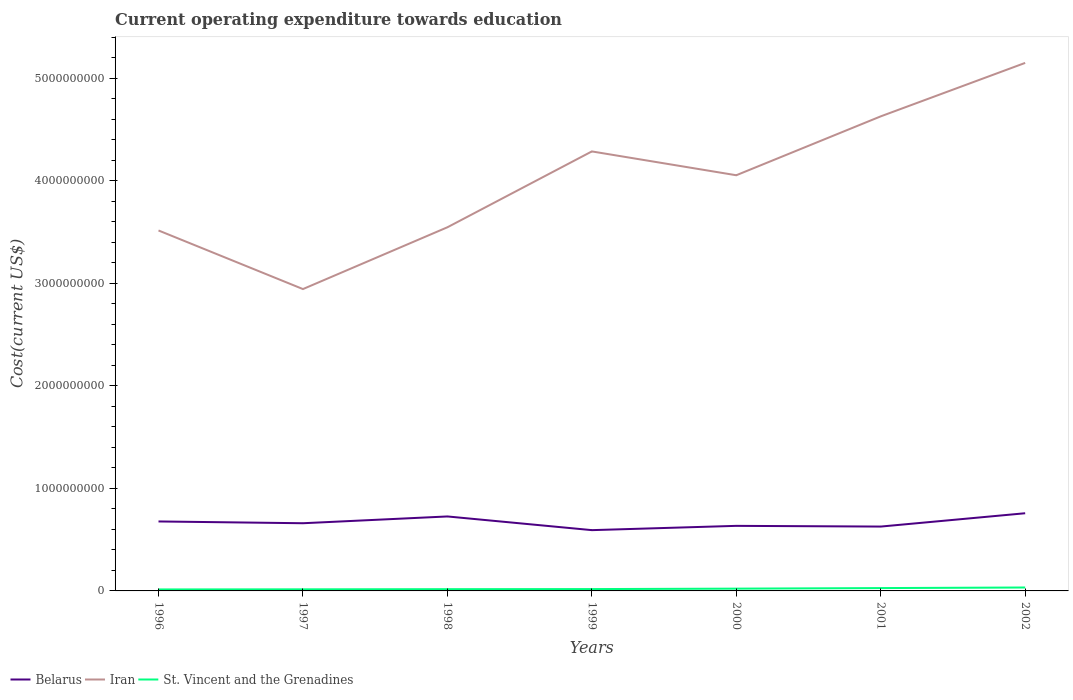How many different coloured lines are there?
Your answer should be compact. 3. Across all years, what is the maximum expenditure towards education in Iran?
Your answer should be very brief. 2.94e+09. In which year was the expenditure towards education in Belarus maximum?
Your answer should be compact. 1999. What is the total expenditure towards education in Belarus in the graph?
Provide a short and direct response. 9.87e+07. What is the difference between the highest and the second highest expenditure towards education in Belarus?
Provide a short and direct response. 1.65e+08. How many years are there in the graph?
Offer a very short reply. 7. Are the values on the major ticks of Y-axis written in scientific E-notation?
Give a very brief answer. No. Does the graph contain any zero values?
Your response must be concise. No. Where does the legend appear in the graph?
Offer a terse response. Bottom left. How are the legend labels stacked?
Make the answer very short. Horizontal. What is the title of the graph?
Make the answer very short. Current operating expenditure towards education. Does "Switzerland" appear as one of the legend labels in the graph?
Provide a succinct answer. No. What is the label or title of the Y-axis?
Your answer should be very brief. Cost(current US$). What is the Cost(current US$) in Belarus in 1996?
Make the answer very short. 6.77e+08. What is the Cost(current US$) in Iran in 1996?
Keep it short and to the point. 3.51e+09. What is the Cost(current US$) in St. Vincent and the Grenadines in 1996?
Provide a short and direct response. 1.44e+07. What is the Cost(current US$) of Belarus in 1997?
Your response must be concise. 6.60e+08. What is the Cost(current US$) of Iran in 1997?
Offer a very short reply. 2.94e+09. What is the Cost(current US$) of St. Vincent and the Grenadines in 1997?
Your response must be concise. 1.55e+07. What is the Cost(current US$) in Belarus in 1998?
Provide a succinct answer. 7.26e+08. What is the Cost(current US$) of Iran in 1998?
Provide a short and direct response. 3.55e+09. What is the Cost(current US$) in St. Vincent and the Grenadines in 1998?
Offer a very short reply. 1.71e+07. What is the Cost(current US$) of Belarus in 1999?
Keep it short and to the point. 5.93e+08. What is the Cost(current US$) of Iran in 1999?
Make the answer very short. 4.29e+09. What is the Cost(current US$) of St. Vincent and the Grenadines in 1999?
Your response must be concise. 1.80e+07. What is the Cost(current US$) of Belarus in 2000?
Ensure brevity in your answer.  6.35e+08. What is the Cost(current US$) of Iran in 2000?
Offer a terse response. 4.05e+09. What is the Cost(current US$) in St. Vincent and the Grenadines in 2000?
Offer a terse response. 2.22e+07. What is the Cost(current US$) in Belarus in 2001?
Your answer should be compact. 6.28e+08. What is the Cost(current US$) in Iran in 2001?
Ensure brevity in your answer.  4.63e+09. What is the Cost(current US$) in St. Vincent and the Grenadines in 2001?
Give a very brief answer. 2.77e+07. What is the Cost(current US$) of Belarus in 2002?
Offer a terse response. 7.57e+08. What is the Cost(current US$) of Iran in 2002?
Your response must be concise. 5.15e+09. What is the Cost(current US$) in St. Vincent and the Grenadines in 2002?
Offer a terse response. 3.33e+07. Across all years, what is the maximum Cost(current US$) in Belarus?
Give a very brief answer. 7.57e+08. Across all years, what is the maximum Cost(current US$) of Iran?
Keep it short and to the point. 5.15e+09. Across all years, what is the maximum Cost(current US$) in St. Vincent and the Grenadines?
Your answer should be very brief. 3.33e+07. Across all years, what is the minimum Cost(current US$) of Belarus?
Keep it short and to the point. 5.93e+08. Across all years, what is the minimum Cost(current US$) in Iran?
Ensure brevity in your answer.  2.94e+09. Across all years, what is the minimum Cost(current US$) in St. Vincent and the Grenadines?
Provide a short and direct response. 1.44e+07. What is the total Cost(current US$) in Belarus in the graph?
Make the answer very short. 4.68e+09. What is the total Cost(current US$) of Iran in the graph?
Your answer should be compact. 2.81e+1. What is the total Cost(current US$) of St. Vincent and the Grenadines in the graph?
Offer a terse response. 1.48e+08. What is the difference between the Cost(current US$) in Belarus in 1996 and that in 1997?
Your answer should be compact. 1.73e+07. What is the difference between the Cost(current US$) of Iran in 1996 and that in 1997?
Your response must be concise. 5.71e+08. What is the difference between the Cost(current US$) of St. Vincent and the Grenadines in 1996 and that in 1997?
Offer a terse response. -1.04e+06. What is the difference between the Cost(current US$) in Belarus in 1996 and that in 1998?
Keep it short and to the point. -4.88e+07. What is the difference between the Cost(current US$) in Iran in 1996 and that in 1998?
Ensure brevity in your answer.  -3.11e+07. What is the difference between the Cost(current US$) of St. Vincent and the Grenadines in 1996 and that in 1998?
Give a very brief answer. -2.66e+06. What is the difference between the Cost(current US$) of Belarus in 1996 and that in 1999?
Keep it short and to the point. 8.47e+07. What is the difference between the Cost(current US$) in Iran in 1996 and that in 1999?
Ensure brevity in your answer.  -7.71e+08. What is the difference between the Cost(current US$) in St. Vincent and the Grenadines in 1996 and that in 1999?
Give a very brief answer. -3.55e+06. What is the difference between the Cost(current US$) of Belarus in 1996 and that in 2000?
Ensure brevity in your answer.  4.29e+07. What is the difference between the Cost(current US$) in Iran in 1996 and that in 2000?
Provide a succinct answer. -5.39e+08. What is the difference between the Cost(current US$) of St. Vincent and the Grenadines in 1996 and that in 2000?
Your response must be concise. -7.82e+06. What is the difference between the Cost(current US$) in Belarus in 1996 and that in 2001?
Offer a terse response. 4.99e+07. What is the difference between the Cost(current US$) of Iran in 1996 and that in 2001?
Your response must be concise. -1.11e+09. What is the difference between the Cost(current US$) of St. Vincent and the Grenadines in 1996 and that in 2001?
Your answer should be very brief. -1.33e+07. What is the difference between the Cost(current US$) in Belarus in 1996 and that in 2002?
Provide a succinct answer. -8.01e+07. What is the difference between the Cost(current US$) in Iran in 1996 and that in 2002?
Your response must be concise. -1.63e+09. What is the difference between the Cost(current US$) of St. Vincent and the Grenadines in 1996 and that in 2002?
Offer a very short reply. -1.89e+07. What is the difference between the Cost(current US$) of Belarus in 1997 and that in 1998?
Provide a short and direct response. -6.61e+07. What is the difference between the Cost(current US$) of Iran in 1997 and that in 1998?
Make the answer very short. -6.02e+08. What is the difference between the Cost(current US$) of St. Vincent and the Grenadines in 1997 and that in 1998?
Offer a terse response. -1.62e+06. What is the difference between the Cost(current US$) in Belarus in 1997 and that in 1999?
Give a very brief answer. 6.73e+07. What is the difference between the Cost(current US$) in Iran in 1997 and that in 1999?
Offer a very short reply. -1.34e+09. What is the difference between the Cost(current US$) in St. Vincent and the Grenadines in 1997 and that in 1999?
Offer a very short reply. -2.51e+06. What is the difference between the Cost(current US$) of Belarus in 1997 and that in 2000?
Give a very brief answer. 2.56e+07. What is the difference between the Cost(current US$) of Iran in 1997 and that in 2000?
Make the answer very short. -1.11e+09. What is the difference between the Cost(current US$) of St. Vincent and the Grenadines in 1997 and that in 2000?
Give a very brief answer. -6.78e+06. What is the difference between the Cost(current US$) in Belarus in 1997 and that in 2001?
Offer a terse response. 3.26e+07. What is the difference between the Cost(current US$) in Iran in 1997 and that in 2001?
Your response must be concise. -1.68e+09. What is the difference between the Cost(current US$) of St. Vincent and the Grenadines in 1997 and that in 2001?
Offer a very short reply. -1.22e+07. What is the difference between the Cost(current US$) in Belarus in 1997 and that in 2002?
Your response must be concise. -9.74e+07. What is the difference between the Cost(current US$) of Iran in 1997 and that in 2002?
Your response must be concise. -2.21e+09. What is the difference between the Cost(current US$) in St. Vincent and the Grenadines in 1997 and that in 2002?
Keep it short and to the point. -1.79e+07. What is the difference between the Cost(current US$) in Belarus in 1998 and that in 1999?
Your answer should be compact. 1.33e+08. What is the difference between the Cost(current US$) of Iran in 1998 and that in 1999?
Provide a short and direct response. -7.40e+08. What is the difference between the Cost(current US$) of St. Vincent and the Grenadines in 1998 and that in 1999?
Provide a short and direct response. -8.95e+05. What is the difference between the Cost(current US$) of Belarus in 1998 and that in 2000?
Give a very brief answer. 9.17e+07. What is the difference between the Cost(current US$) in Iran in 1998 and that in 2000?
Give a very brief answer. -5.07e+08. What is the difference between the Cost(current US$) of St. Vincent and the Grenadines in 1998 and that in 2000?
Provide a succinct answer. -5.16e+06. What is the difference between the Cost(current US$) in Belarus in 1998 and that in 2001?
Your response must be concise. 9.87e+07. What is the difference between the Cost(current US$) in Iran in 1998 and that in 2001?
Ensure brevity in your answer.  -1.08e+09. What is the difference between the Cost(current US$) in St. Vincent and the Grenadines in 1998 and that in 2001?
Provide a succinct answer. -1.06e+07. What is the difference between the Cost(current US$) of Belarus in 1998 and that in 2002?
Ensure brevity in your answer.  -3.13e+07. What is the difference between the Cost(current US$) in Iran in 1998 and that in 2002?
Your answer should be very brief. -1.60e+09. What is the difference between the Cost(current US$) of St. Vincent and the Grenadines in 1998 and that in 2002?
Your answer should be compact. -1.62e+07. What is the difference between the Cost(current US$) in Belarus in 1999 and that in 2000?
Ensure brevity in your answer.  -4.18e+07. What is the difference between the Cost(current US$) of Iran in 1999 and that in 2000?
Ensure brevity in your answer.  2.32e+08. What is the difference between the Cost(current US$) of St. Vincent and the Grenadines in 1999 and that in 2000?
Keep it short and to the point. -4.27e+06. What is the difference between the Cost(current US$) of Belarus in 1999 and that in 2001?
Ensure brevity in your answer.  -3.48e+07. What is the difference between the Cost(current US$) of Iran in 1999 and that in 2001?
Provide a short and direct response. -3.42e+08. What is the difference between the Cost(current US$) of St. Vincent and the Grenadines in 1999 and that in 2001?
Keep it short and to the point. -9.73e+06. What is the difference between the Cost(current US$) of Belarus in 1999 and that in 2002?
Provide a short and direct response. -1.65e+08. What is the difference between the Cost(current US$) of Iran in 1999 and that in 2002?
Give a very brief answer. -8.63e+08. What is the difference between the Cost(current US$) in St. Vincent and the Grenadines in 1999 and that in 2002?
Offer a very short reply. -1.53e+07. What is the difference between the Cost(current US$) in Belarus in 2000 and that in 2001?
Make the answer very short. 7.00e+06. What is the difference between the Cost(current US$) in Iran in 2000 and that in 2001?
Provide a short and direct response. -5.74e+08. What is the difference between the Cost(current US$) in St. Vincent and the Grenadines in 2000 and that in 2001?
Make the answer very short. -5.46e+06. What is the difference between the Cost(current US$) in Belarus in 2000 and that in 2002?
Offer a terse response. -1.23e+08. What is the difference between the Cost(current US$) in Iran in 2000 and that in 2002?
Provide a short and direct response. -1.10e+09. What is the difference between the Cost(current US$) in St. Vincent and the Grenadines in 2000 and that in 2002?
Your response must be concise. -1.11e+07. What is the difference between the Cost(current US$) of Belarus in 2001 and that in 2002?
Make the answer very short. -1.30e+08. What is the difference between the Cost(current US$) of Iran in 2001 and that in 2002?
Your answer should be compact. -5.21e+08. What is the difference between the Cost(current US$) in St. Vincent and the Grenadines in 2001 and that in 2002?
Keep it short and to the point. -5.61e+06. What is the difference between the Cost(current US$) of Belarus in 1996 and the Cost(current US$) of Iran in 1997?
Your answer should be compact. -2.27e+09. What is the difference between the Cost(current US$) in Belarus in 1996 and the Cost(current US$) in St. Vincent and the Grenadines in 1997?
Your answer should be compact. 6.62e+08. What is the difference between the Cost(current US$) in Iran in 1996 and the Cost(current US$) in St. Vincent and the Grenadines in 1997?
Provide a succinct answer. 3.50e+09. What is the difference between the Cost(current US$) in Belarus in 1996 and the Cost(current US$) in Iran in 1998?
Provide a short and direct response. -2.87e+09. What is the difference between the Cost(current US$) of Belarus in 1996 and the Cost(current US$) of St. Vincent and the Grenadines in 1998?
Provide a succinct answer. 6.60e+08. What is the difference between the Cost(current US$) of Iran in 1996 and the Cost(current US$) of St. Vincent and the Grenadines in 1998?
Offer a very short reply. 3.50e+09. What is the difference between the Cost(current US$) of Belarus in 1996 and the Cost(current US$) of Iran in 1999?
Your answer should be very brief. -3.61e+09. What is the difference between the Cost(current US$) in Belarus in 1996 and the Cost(current US$) in St. Vincent and the Grenadines in 1999?
Your answer should be compact. 6.59e+08. What is the difference between the Cost(current US$) of Iran in 1996 and the Cost(current US$) of St. Vincent and the Grenadines in 1999?
Your answer should be compact. 3.50e+09. What is the difference between the Cost(current US$) in Belarus in 1996 and the Cost(current US$) in Iran in 2000?
Your response must be concise. -3.38e+09. What is the difference between the Cost(current US$) of Belarus in 1996 and the Cost(current US$) of St. Vincent and the Grenadines in 2000?
Offer a terse response. 6.55e+08. What is the difference between the Cost(current US$) in Iran in 1996 and the Cost(current US$) in St. Vincent and the Grenadines in 2000?
Ensure brevity in your answer.  3.49e+09. What is the difference between the Cost(current US$) of Belarus in 1996 and the Cost(current US$) of Iran in 2001?
Ensure brevity in your answer.  -3.95e+09. What is the difference between the Cost(current US$) of Belarus in 1996 and the Cost(current US$) of St. Vincent and the Grenadines in 2001?
Offer a terse response. 6.50e+08. What is the difference between the Cost(current US$) in Iran in 1996 and the Cost(current US$) in St. Vincent and the Grenadines in 2001?
Provide a succinct answer. 3.49e+09. What is the difference between the Cost(current US$) in Belarus in 1996 and the Cost(current US$) in Iran in 2002?
Make the answer very short. -4.47e+09. What is the difference between the Cost(current US$) of Belarus in 1996 and the Cost(current US$) of St. Vincent and the Grenadines in 2002?
Provide a short and direct response. 6.44e+08. What is the difference between the Cost(current US$) of Iran in 1996 and the Cost(current US$) of St. Vincent and the Grenadines in 2002?
Offer a very short reply. 3.48e+09. What is the difference between the Cost(current US$) in Belarus in 1997 and the Cost(current US$) in Iran in 1998?
Make the answer very short. -2.89e+09. What is the difference between the Cost(current US$) of Belarus in 1997 and the Cost(current US$) of St. Vincent and the Grenadines in 1998?
Offer a very short reply. 6.43e+08. What is the difference between the Cost(current US$) in Iran in 1997 and the Cost(current US$) in St. Vincent and the Grenadines in 1998?
Ensure brevity in your answer.  2.93e+09. What is the difference between the Cost(current US$) of Belarus in 1997 and the Cost(current US$) of Iran in 1999?
Offer a very short reply. -3.63e+09. What is the difference between the Cost(current US$) of Belarus in 1997 and the Cost(current US$) of St. Vincent and the Grenadines in 1999?
Your answer should be very brief. 6.42e+08. What is the difference between the Cost(current US$) of Iran in 1997 and the Cost(current US$) of St. Vincent and the Grenadines in 1999?
Give a very brief answer. 2.93e+09. What is the difference between the Cost(current US$) in Belarus in 1997 and the Cost(current US$) in Iran in 2000?
Offer a very short reply. -3.39e+09. What is the difference between the Cost(current US$) in Belarus in 1997 and the Cost(current US$) in St. Vincent and the Grenadines in 2000?
Offer a very short reply. 6.38e+08. What is the difference between the Cost(current US$) of Iran in 1997 and the Cost(current US$) of St. Vincent and the Grenadines in 2000?
Keep it short and to the point. 2.92e+09. What is the difference between the Cost(current US$) in Belarus in 1997 and the Cost(current US$) in Iran in 2001?
Keep it short and to the point. -3.97e+09. What is the difference between the Cost(current US$) in Belarus in 1997 and the Cost(current US$) in St. Vincent and the Grenadines in 2001?
Offer a terse response. 6.32e+08. What is the difference between the Cost(current US$) of Iran in 1997 and the Cost(current US$) of St. Vincent and the Grenadines in 2001?
Provide a short and direct response. 2.92e+09. What is the difference between the Cost(current US$) of Belarus in 1997 and the Cost(current US$) of Iran in 2002?
Offer a terse response. -4.49e+09. What is the difference between the Cost(current US$) of Belarus in 1997 and the Cost(current US$) of St. Vincent and the Grenadines in 2002?
Your answer should be very brief. 6.27e+08. What is the difference between the Cost(current US$) of Iran in 1997 and the Cost(current US$) of St. Vincent and the Grenadines in 2002?
Offer a very short reply. 2.91e+09. What is the difference between the Cost(current US$) of Belarus in 1998 and the Cost(current US$) of Iran in 1999?
Give a very brief answer. -3.56e+09. What is the difference between the Cost(current US$) in Belarus in 1998 and the Cost(current US$) in St. Vincent and the Grenadines in 1999?
Your answer should be very brief. 7.08e+08. What is the difference between the Cost(current US$) in Iran in 1998 and the Cost(current US$) in St. Vincent and the Grenadines in 1999?
Your response must be concise. 3.53e+09. What is the difference between the Cost(current US$) in Belarus in 1998 and the Cost(current US$) in Iran in 2000?
Provide a short and direct response. -3.33e+09. What is the difference between the Cost(current US$) of Belarus in 1998 and the Cost(current US$) of St. Vincent and the Grenadines in 2000?
Ensure brevity in your answer.  7.04e+08. What is the difference between the Cost(current US$) of Iran in 1998 and the Cost(current US$) of St. Vincent and the Grenadines in 2000?
Provide a succinct answer. 3.52e+09. What is the difference between the Cost(current US$) of Belarus in 1998 and the Cost(current US$) of Iran in 2001?
Offer a terse response. -3.90e+09. What is the difference between the Cost(current US$) of Belarus in 1998 and the Cost(current US$) of St. Vincent and the Grenadines in 2001?
Ensure brevity in your answer.  6.98e+08. What is the difference between the Cost(current US$) in Iran in 1998 and the Cost(current US$) in St. Vincent and the Grenadines in 2001?
Your answer should be compact. 3.52e+09. What is the difference between the Cost(current US$) in Belarus in 1998 and the Cost(current US$) in Iran in 2002?
Provide a succinct answer. -4.42e+09. What is the difference between the Cost(current US$) in Belarus in 1998 and the Cost(current US$) in St. Vincent and the Grenadines in 2002?
Your answer should be very brief. 6.93e+08. What is the difference between the Cost(current US$) in Iran in 1998 and the Cost(current US$) in St. Vincent and the Grenadines in 2002?
Ensure brevity in your answer.  3.51e+09. What is the difference between the Cost(current US$) of Belarus in 1999 and the Cost(current US$) of Iran in 2000?
Keep it short and to the point. -3.46e+09. What is the difference between the Cost(current US$) of Belarus in 1999 and the Cost(current US$) of St. Vincent and the Grenadines in 2000?
Your answer should be very brief. 5.70e+08. What is the difference between the Cost(current US$) in Iran in 1999 and the Cost(current US$) in St. Vincent and the Grenadines in 2000?
Offer a very short reply. 4.26e+09. What is the difference between the Cost(current US$) in Belarus in 1999 and the Cost(current US$) in Iran in 2001?
Ensure brevity in your answer.  -4.03e+09. What is the difference between the Cost(current US$) in Belarus in 1999 and the Cost(current US$) in St. Vincent and the Grenadines in 2001?
Ensure brevity in your answer.  5.65e+08. What is the difference between the Cost(current US$) in Iran in 1999 and the Cost(current US$) in St. Vincent and the Grenadines in 2001?
Provide a short and direct response. 4.26e+09. What is the difference between the Cost(current US$) of Belarus in 1999 and the Cost(current US$) of Iran in 2002?
Your response must be concise. -4.56e+09. What is the difference between the Cost(current US$) in Belarus in 1999 and the Cost(current US$) in St. Vincent and the Grenadines in 2002?
Make the answer very short. 5.59e+08. What is the difference between the Cost(current US$) in Iran in 1999 and the Cost(current US$) in St. Vincent and the Grenadines in 2002?
Your answer should be very brief. 4.25e+09. What is the difference between the Cost(current US$) in Belarus in 2000 and the Cost(current US$) in Iran in 2001?
Your answer should be compact. -3.99e+09. What is the difference between the Cost(current US$) in Belarus in 2000 and the Cost(current US$) in St. Vincent and the Grenadines in 2001?
Give a very brief answer. 6.07e+08. What is the difference between the Cost(current US$) in Iran in 2000 and the Cost(current US$) in St. Vincent and the Grenadines in 2001?
Your response must be concise. 4.03e+09. What is the difference between the Cost(current US$) of Belarus in 2000 and the Cost(current US$) of Iran in 2002?
Your answer should be very brief. -4.51e+09. What is the difference between the Cost(current US$) of Belarus in 2000 and the Cost(current US$) of St. Vincent and the Grenadines in 2002?
Offer a terse response. 6.01e+08. What is the difference between the Cost(current US$) in Iran in 2000 and the Cost(current US$) in St. Vincent and the Grenadines in 2002?
Give a very brief answer. 4.02e+09. What is the difference between the Cost(current US$) of Belarus in 2001 and the Cost(current US$) of Iran in 2002?
Offer a very short reply. -4.52e+09. What is the difference between the Cost(current US$) in Belarus in 2001 and the Cost(current US$) in St. Vincent and the Grenadines in 2002?
Your answer should be compact. 5.94e+08. What is the difference between the Cost(current US$) in Iran in 2001 and the Cost(current US$) in St. Vincent and the Grenadines in 2002?
Provide a succinct answer. 4.59e+09. What is the average Cost(current US$) of Belarus per year?
Your response must be concise. 6.68e+08. What is the average Cost(current US$) in Iran per year?
Your response must be concise. 4.02e+09. What is the average Cost(current US$) of St. Vincent and the Grenadines per year?
Give a very brief answer. 2.12e+07. In the year 1996, what is the difference between the Cost(current US$) of Belarus and Cost(current US$) of Iran?
Provide a short and direct response. -2.84e+09. In the year 1996, what is the difference between the Cost(current US$) in Belarus and Cost(current US$) in St. Vincent and the Grenadines?
Your response must be concise. 6.63e+08. In the year 1996, what is the difference between the Cost(current US$) in Iran and Cost(current US$) in St. Vincent and the Grenadines?
Offer a terse response. 3.50e+09. In the year 1997, what is the difference between the Cost(current US$) in Belarus and Cost(current US$) in Iran?
Provide a short and direct response. -2.28e+09. In the year 1997, what is the difference between the Cost(current US$) of Belarus and Cost(current US$) of St. Vincent and the Grenadines?
Make the answer very short. 6.45e+08. In the year 1997, what is the difference between the Cost(current US$) in Iran and Cost(current US$) in St. Vincent and the Grenadines?
Provide a succinct answer. 2.93e+09. In the year 1998, what is the difference between the Cost(current US$) of Belarus and Cost(current US$) of Iran?
Your answer should be very brief. -2.82e+09. In the year 1998, what is the difference between the Cost(current US$) in Belarus and Cost(current US$) in St. Vincent and the Grenadines?
Offer a terse response. 7.09e+08. In the year 1998, what is the difference between the Cost(current US$) of Iran and Cost(current US$) of St. Vincent and the Grenadines?
Ensure brevity in your answer.  3.53e+09. In the year 1999, what is the difference between the Cost(current US$) of Belarus and Cost(current US$) of Iran?
Your answer should be compact. -3.69e+09. In the year 1999, what is the difference between the Cost(current US$) of Belarus and Cost(current US$) of St. Vincent and the Grenadines?
Offer a terse response. 5.75e+08. In the year 1999, what is the difference between the Cost(current US$) of Iran and Cost(current US$) of St. Vincent and the Grenadines?
Your response must be concise. 4.27e+09. In the year 2000, what is the difference between the Cost(current US$) of Belarus and Cost(current US$) of Iran?
Provide a short and direct response. -3.42e+09. In the year 2000, what is the difference between the Cost(current US$) in Belarus and Cost(current US$) in St. Vincent and the Grenadines?
Your response must be concise. 6.12e+08. In the year 2000, what is the difference between the Cost(current US$) in Iran and Cost(current US$) in St. Vincent and the Grenadines?
Make the answer very short. 4.03e+09. In the year 2001, what is the difference between the Cost(current US$) in Belarus and Cost(current US$) in Iran?
Provide a succinct answer. -4.00e+09. In the year 2001, what is the difference between the Cost(current US$) of Belarus and Cost(current US$) of St. Vincent and the Grenadines?
Offer a terse response. 6.00e+08. In the year 2001, what is the difference between the Cost(current US$) of Iran and Cost(current US$) of St. Vincent and the Grenadines?
Ensure brevity in your answer.  4.60e+09. In the year 2002, what is the difference between the Cost(current US$) in Belarus and Cost(current US$) in Iran?
Your answer should be compact. -4.39e+09. In the year 2002, what is the difference between the Cost(current US$) in Belarus and Cost(current US$) in St. Vincent and the Grenadines?
Provide a short and direct response. 7.24e+08. In the year 2002, what is the difference between the Cost(current US$) in Iran and Cost(current US$) in St. Vincent and the Grenadines?
Your answer should be compact. 5.12e+09. What is the ratio of the Cost(current US$) of Belarus in 1996 to that in 1997?
Offer a terse response. 1.03. What is the ratio of the Cost(current US$) in Iran in 1996 to that in 1997?
Offer a very short reply. 1.19. What is the ratio of the Cost(current US$) in St. Vincent and the Grenadines in 1996 to that in 1997?
Your response must be concise. 0.93. What is the ratio of the Cost(current US$) in Belarus in 1996 to that in 1998?
Offer a very short reply. 0.93. What is the ratio of the Cost(current US$) in St. Vincent and the Grenadines in 1996 to that in 1998?
Keep it short and to the point. 0.84. What is the ratio of the Cost(current US$) in Belarus in 1996 to that in 1999?
Make the answer very short. 1.14. What is the ratio of the Cost(current US$) of Iran in 1996 to that in 1999?
Offer a terse response. 0.82. What is the ratio of the Cost(current US$) of St. Vincent and the Grenadines in 1996 to that in 1999?
Offer a terse response. 0.8. What is the ratio of the Cost(current US$) of Belarus in 1996 to that in 2000?
Provide a succinct answer. 1.07. What is the ratio of the Cost(current US$) in Iran in 1996 to that in 2000?
Ensure brevity in your answer.  0.87. What is the ratio of the Cost(current US$) in St. Vincent and the Grenadines in 1996 to that in 2000?
Your answer should be very brief. 0.65. What is the ratio of the Cost(current US$) of Belarus in 1996 to that in 2001?
Provide a succinct answer. 1.08. What is the ratio of the Cost(current US$) in Iran in 1996 to that in 2001?
Your answer should be compact. 0.76. What is the ratio of the Cost(current US$) of St. Vincent and the Grenadines in 1996 to that in 2001?
Offer a terse response. 0.52. What is the ratio of the Cost(current US$) of Belarus in 1996 to that in 2002?
Give a very brief answer. 0.89. What is the ratio of the Cost(current US$) in Iran in 1996 to that in 2002?
Keep it short and to the point. 0.68. What is the ratio of the Cost(current US$) of St. Vincent and the Grenadines in 1996 to that in 2002?
Provide a short and direct response. 0.43. What is the ratio of the Cost(current US$) in Belarus in 1997 to that in 1998?
Your answer should be compact. 0.91. What is the ratio of the Cost(current US$) in Iran in 1997 to that in 1998?
Your answer should be compact. 0.83. What is the ratio of the Cost(current US$) in St. Vincent and the Grenadines in 1997 to that in 1998?
Make the answer very short. 0.91. What is the ratio of the Cost(current US$) in Belarus in 1997 to that in 1999?
Offer a terse response. 1.11. What is the ratio of the Cost(current US$) in Iran in 1997 to that in 1999?
Offer a terse response. 0.69. What is the ratio of the Cost(current US$) of St. Vincent and the Grenadines in 1997 to that in 1999?
Your response must be concise. 0.86. What is the ratio of the Cost(current US$) in Belarus in 1997 to that in 2000?
Give a very brief answer. 1.04. What is the ratio of the Cost(current US$) of Iran in 1997 to that in 2000?
Provide a succinct answer. 0.73. What is the ratio of the Cost(current US$) of St. Vincent and the Grenadines in 1997 to that in 2000?
Provide a succinct answer. 0.7. What is the ratio of the Cost(current US$) of Belarus in 1997 to that in 2001?
Your answer should be very brief. 1.05. What is the ratio of the Cost(current US$) in Iran in 1997 to that in 2001?
Keep it short and to the point. 0.64. What is the ratio of the Cost(current US$) in St. Vincent and the Grenadines in 1997 to that in 2001?
Provide a succinct answer. 0.56. What is the ratio of the Cost(current US$) in Belarus in 1997 to that in 2002?
Your answer should be very brief. 0.87. What is the ratio of the Cost(current US$) of Iran in 1997 to that in 2002?
Your answer should be compact. 0.57. What is the ratio of the Cost(current US$) of St. Vincent and the Grenadines in 1997 to that in 2002?
Give a very brief answer. 0.46. What is the ratio of the Cost(current US$) in Belarus in 1998 to that in 1999?
Provide a short and direct response. 1.23. What is the ratio of the Cost(current US$) of Iran in 1998 to that in 1999?
Your response must be concise. 0.83. What is the ratio of the Cost(current US$) in St. Vincent and the Grenadines in 1998 to that in 1999?
Your answer should be very brief. 0.95. What is the ratio of the Cost(current US$) of Belarus in 1998 to that in 2000?
Your answer should be very brief. 1.14. What is the ratio of the Cost(current US$) in Iran in 1998 to that in 2000?
Your answer should be very brief. 0.87. What is the ratio of the Cost(current US$) of St. Vincent and the Grenadines in 1998 to that in 2000?
Keep it short and to the point. 0.77. What is the ratio of the Cost(current US$) in Belarus in 1998 to that in 2001?
Provide a short and direct response. 1.16. What is the ratio of the Cost(current US$) in Iran in 1998 to that in 2001?
Ensure brevity in your answer.  0.77. What is the ratio of the Cost(current US$) in St. Vincent and the Grenadines in 1998 to that in 2001?
Your answer should be very brief. 0.62. What is the ratio of the Cost(current US$) of Belarus in 1998 to that in 2002?
Provide a succinct answer. 0.96. What is the ratio of the Cost(current US$) in Iran in 1998 to that in 2002?
Make the answer very short. 0.69. What is the ratio of the Cost(current US$) of St. Vincent and the Grenadines in 1998 to that in 2002?
Your response must be concise. 0.51. What is the ratio of the Cost(current US$) in Belarus in 1999 to that in 2000?
Keep it short and to the point. 0.93. What is the ratio of the Cost(current US$) of Iran in 1999 to that in 2000?
Ensure brevity in your answer.  1.06. What is the ratio of the Cost(current US$) of St. Vincent and the Grenadines in 1999 to that in 2000?
Give a very brief answer. 0.81. What is the ratio of the Cost(current US$) in Belarus in 1999 to that in 2001?
Provide a succinct answer. 0.94. What is the ratio of the Cost(current US$) of Iran in 1999 to that in 2001?
Provide a short and direct response. 0.93. What is the ratio of the Cost(current US$) of St. Vincent and the Grenadines in 1999 to that in 2001?
Offer a terse response. 0.65. What is the ratio of the Cost(current US$) of Belarus in 1999 to that in 2002?
Make the answer very short. 0.78. What is the ratio of the Cost(current US$) of Iran in 1999 to that in 2002?
Provide a succinct answer. 0.83. What is the ratio of the Cost(current US$) of St. Vincent and the Grenadines in 1999 to that in 2002?
Provide a succinct answer. 0.54. What is the ratio of the Cost(current US$) in Belarus in 2000 to that in 2001?
Your answer should be very brief. 1.01. What is the ratio of the Cost(current US$) of Iran in 2000 to that in 2001?
Give a very brief answer. 0.88. What is the ratio of the Cost(current US$) in St. Vincent and the Grenadines in 2000 to that in 2001?
Offer a terse response. 0.8. What is the ratio of the Cost(current US$) in Belarus in 2000 to that in 2002?
Ensure brevity in your answer.  0.84. What is the ratio of the Cost(current US$) in Iran in 2000 to that in 2002?
Ensure brevity in your answer.  0.79. What is the ratio of the Cost(current US$) in St. Vincent and the Grenadines in 2000 to that in 2002?
Keep it short and to the point. 0.67. What is the ratio of the Cost(current US$) in Belarus in 2001 to that in 2002?
Provide a short and direct response. 0.83. What is the ratio of the Cost(current US$) in Iran in 2001 to that in 2002?
Make the answer very short. 0.9. What is the ratio of the Cost(current US$) in St. Vincent and the Grenadines in 2001 to that in 2002?
Offer a terse response. 0.83. What is the difference between the highest and the second highest Cost(current US$) of Belarus?
Provide a short and direct response. 3.13e+07. What is the difference between the highest and the second highest Cost(current US$) in Iran?
Provide a succinct answer. 5.21e+08. What is the difference between the highest and the second highest Cost(current US$) in St. Vincent and the Grenadines?
Ensure brevity in your answer.  5.61e+06. What is the difference between the highest and the lowest Cost(current US$) in Belarus?
Your answer should be compact. 1.65e+08. What is the difference between the highest and the lowest Cost(current US$) in Iran?
Provide a succinct answer. 2.21e+09. What is the difference between the highest and the lowest Cost(current US$) of St. Vincent and the Grenadines?
Give a very brief answer. 1.89e+07. 